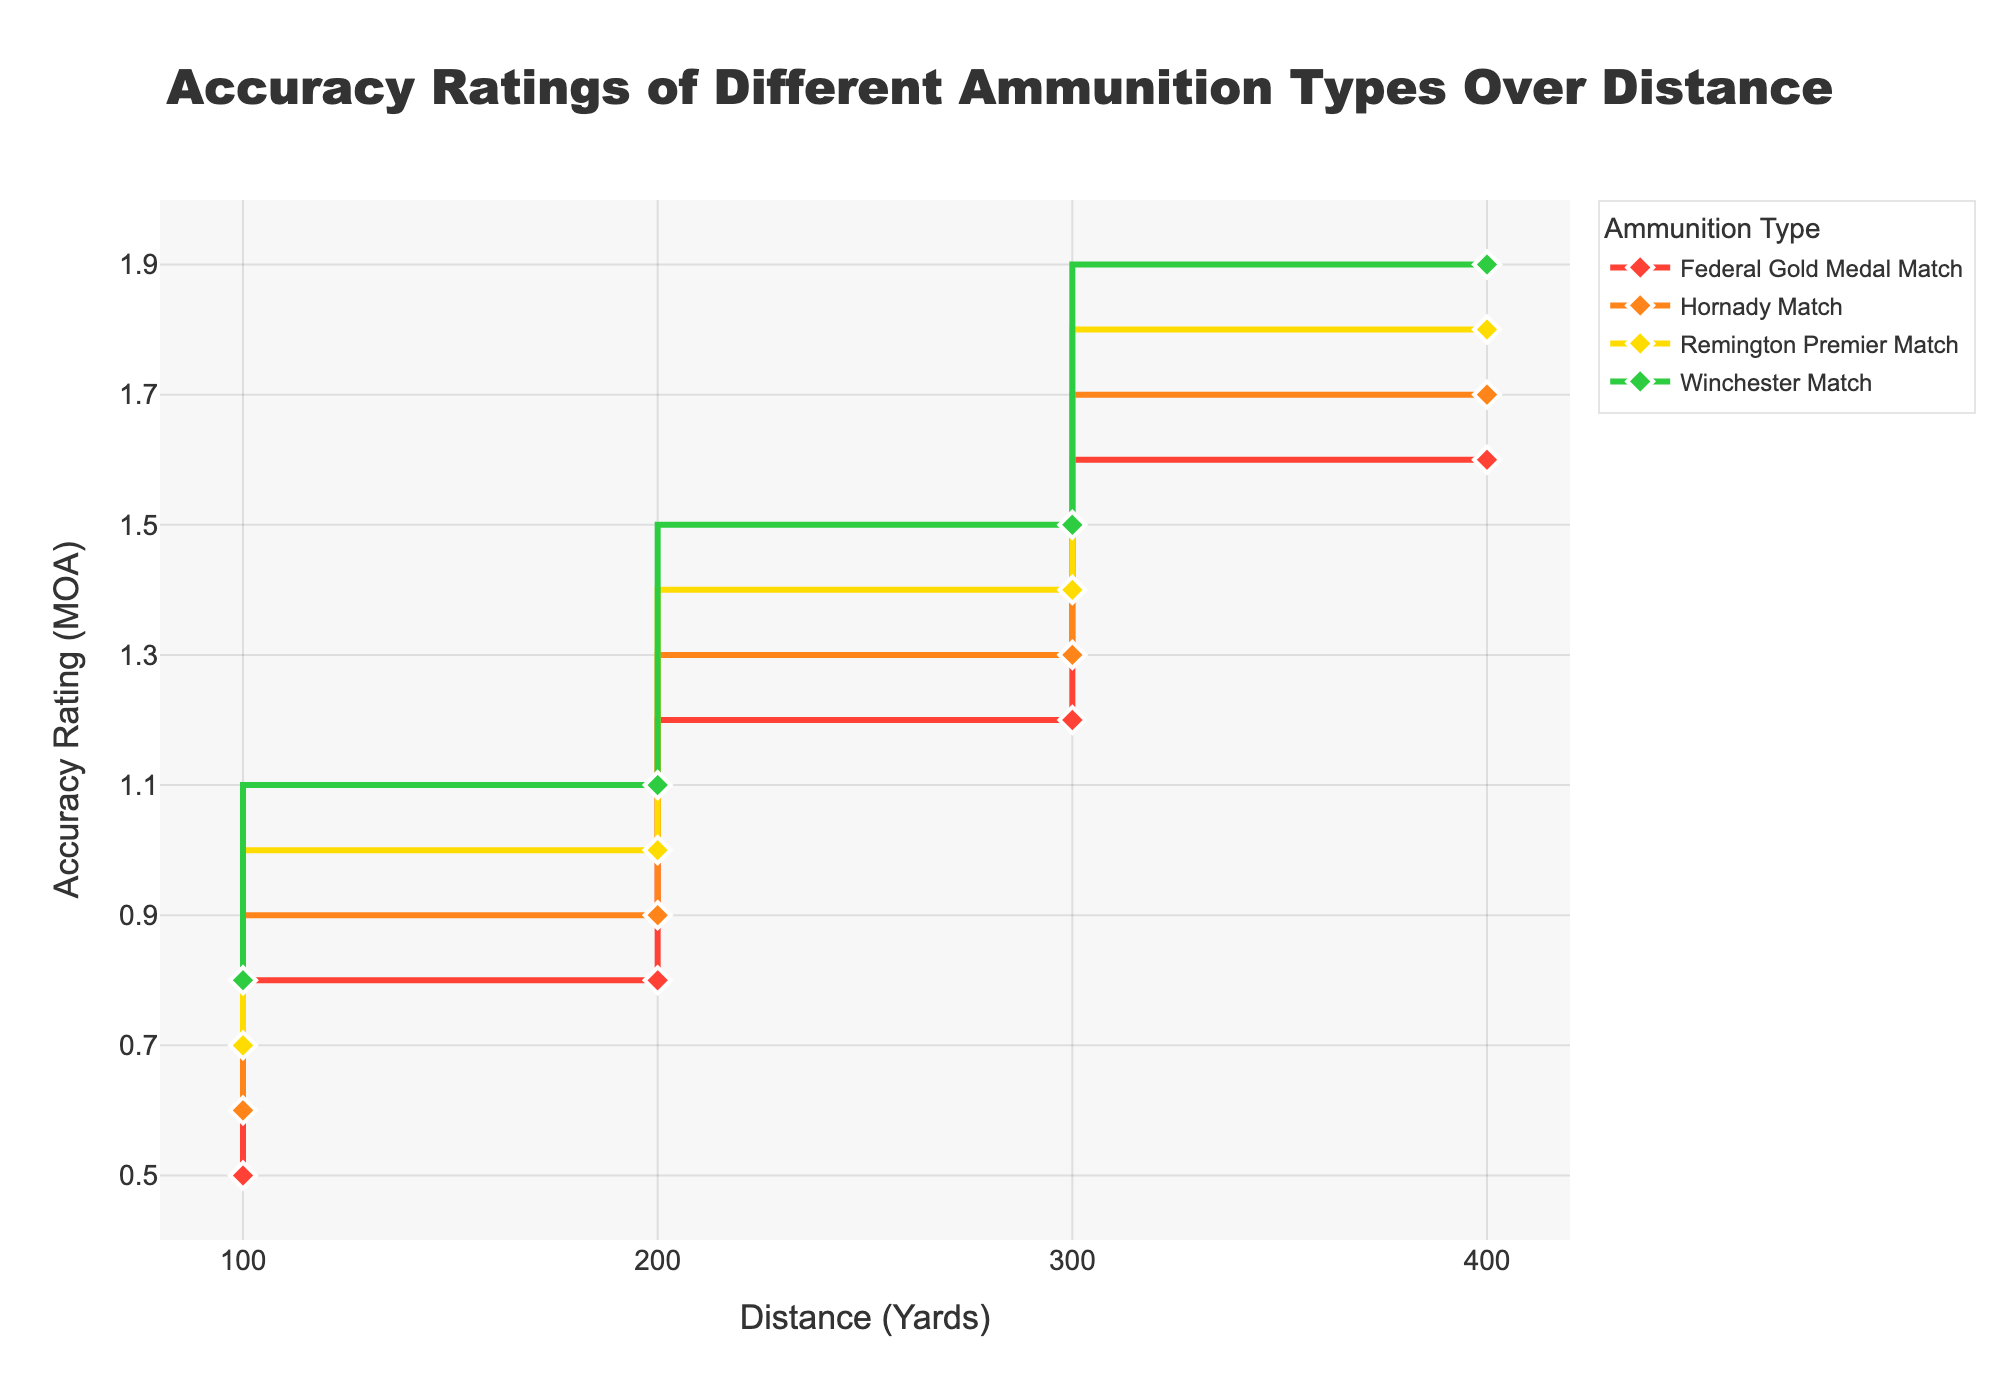What's the title of the figure? The title is usually located at the top of the figure. In this case, the title of the figure is "Accuracy Ratings of Different Ammunition Types Over Distance."
Answer: Accuracy Ratings of Different Ammunition Types Over Distance What are the units of measurement on the x-axis? The x-axis represents distance, and the units are given in yards. This is evident from the label "Distance (Yards)."
Answer: Yards How many ammunition types are there in the figure? Each ammunition type has a separate line with its name in the legend. There are four different ammunition types shown in the legend.
Answer: Four What color represents the Hornady Match ammunition? By looking at the lines and matching them with the legends, the Hornady Match ammunition line is represented by a specific color listed in the legend.
Answer: Orange At 300 yards, which ammunition type has the lowest Accuracy Rating? To find this, scan the 300-yard point on the x-axis for each line and compare their y-axis values. The line with the lowest point at 300 yards represents the ammunition type with the lowest rating.
Answer: Federal Gold Medal Match Which ammunition shows the greatest increase in Accuracy Rating from 100 to 400 yards? Calculate the differences in Accuracy Ratings between 100 and 400 yards for each ammunition type and compare them. The greater the difference, the more the increase.
Answer: Winchester Match What is the average Accuracy Rating of Federal Gold Medal Match across all distances? Add up the Accuracy Ratings at 100, 200, 300, and 400 yards for Federal Gold Medal Match and divide by the number of data points (4).
Answer: 1.025 MOA How does the Accuracy Rating change with distance for all ammunition types? Observe the trend of each line as the distance increases. Typically, for all ammunition types shown, the Accuracy Rating increases as the distance increases.
Answer: Increases What is the difference in Accuracy Ratings between the Hornady Match and Remington Premier Match at 200 yards? Note the Accuracy Rating (MOA) values for Hornady Match and Remington Premier Match at 200 yards and subtract them.
Answer: 0.1 MOA Which ammunition has the highest Accuracy Rating at 400 yards? Compare the Accuracy Ratings at the 400-yard mark for each ammunition type directly. The highest point indicates the ammunition with the highest Accuracy Rating.
Answer: Winchester Match 